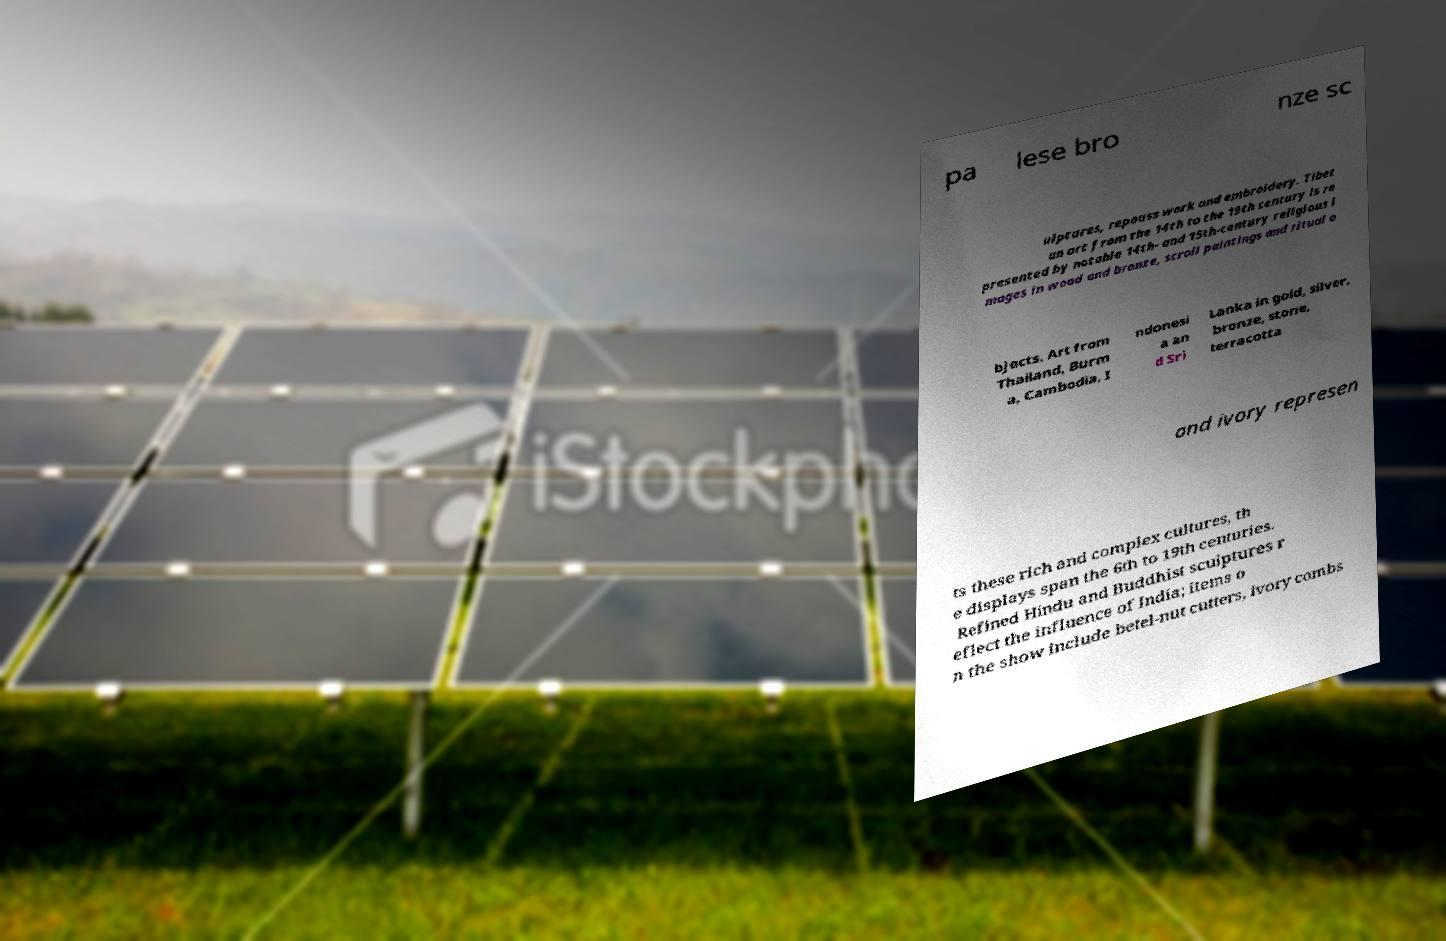What messages or text are displayed in this image? I need them in a readable, typed format. pa lese bro nze sc ulptures, repouss work and embroidery. Tibet an art from the 14th to the 19th century is re presented by notable 14th- and 15th-century religious i mages in wood and bronze, scroll paintings and ritual o bjects. Art from Thailand, Burm a, Cambodia, I ndonesi a an d Sri Lanka in gold, silver, bronze, stone, terracotta and ivory represen ts these rich and complex cultures, th e displays span the 6th to 19th centuries. Refined Hindu and Buddhist sculptures r eflect the influence of India; items o n the show include betel-nut cutters, ivory combs 